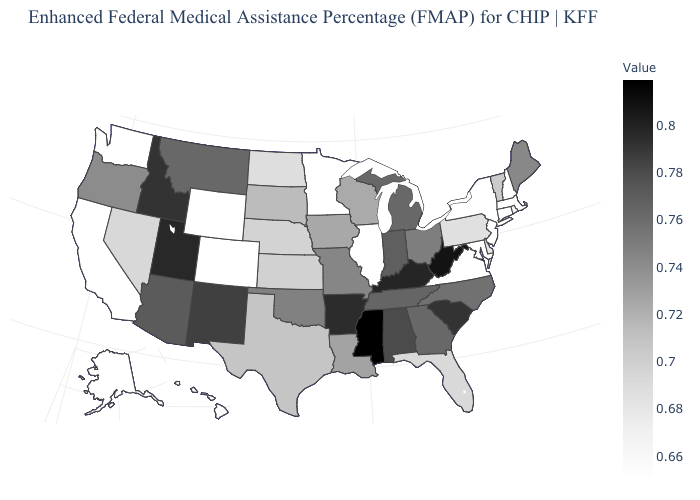Is the legend a continuous bar?
Be succinct. Yes. Which states have the highest value in the USA?
Be succinct. Mississippi. 